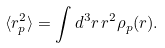Convert formula to latex. <formula><loc_0><loc_0><loc_500><loc_500>\langle r _ { p } ^ { 2 } \rangle = \int d ^ { 3 } r \, r ^ { 2 } \rho _ { p } ( r ) .</formula> 